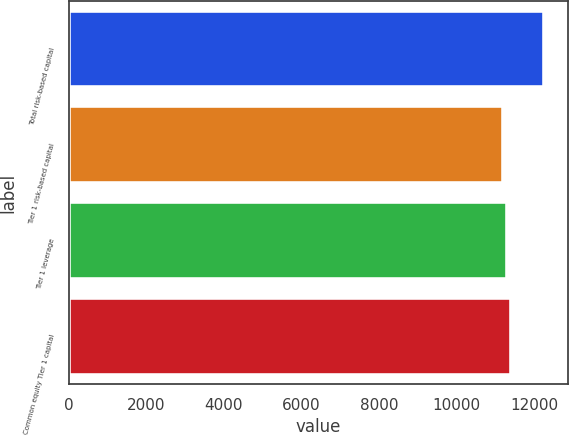Convert chart. <chart><loc_0><loc_0><loc_500><loc_500><bar_chart><fcel>Total risk-based capital<fcel>Tier 1 risk-based capital<fcel>Tier 1 leverage<fcel>Common equity Tier 1 capital<nl><fcel>12258<fcel>11207<fcel>11312.1<fcel>11417.2<nl></chart> 